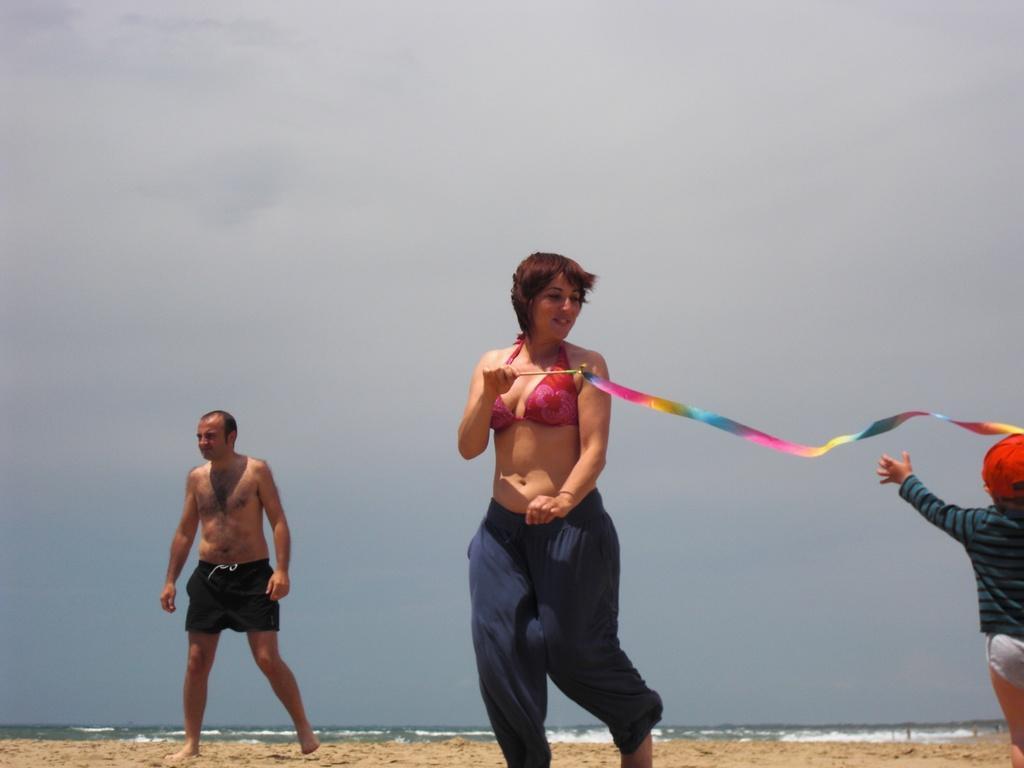Please provide a concise description of this image. In this image we can see three persons. The person in the middle is holding an object. At the bottom we can see the sand and the water. Behind the persons we can see the sky. 